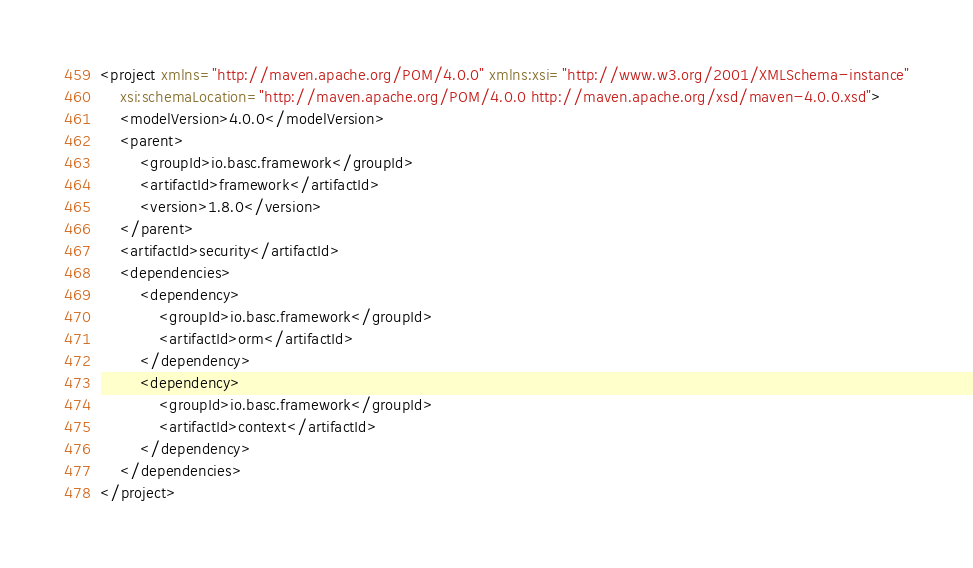Convert code to text. <code><loc_0><loc_0><loc_500><loc_500><_XML_><project xmlns="http://maven.apache.org/POM/4.0.0" xmlns:xsi="http://www.w3.org/2001/XMLSchema-instance"
	xsi:schemaLocation="http://maven.apache.org/POM/4.0.0 http://maven.apache.org/xsd/maven-4.0.0.xsd">
	<modelVersion>4.0.0</modelVersion>
	<parent>
		<groupId>io.basc.framework</groupId>
		<artifactId>framework</artifactId>
		<version>1.8.0</version>
	</parent>
	<artifactId>security</artifactId>
	<dependencies>
		<dependency>
			<groupId>io.basc.framework</groupId>
			<artifactId>orm</artifactId>
		</dependency>
		<dependency>
			<groupId>io.basc.framework</groupId>
			<artifactId>context</artifactId>
		</dependency>
	</dependencies>
</project></code> 